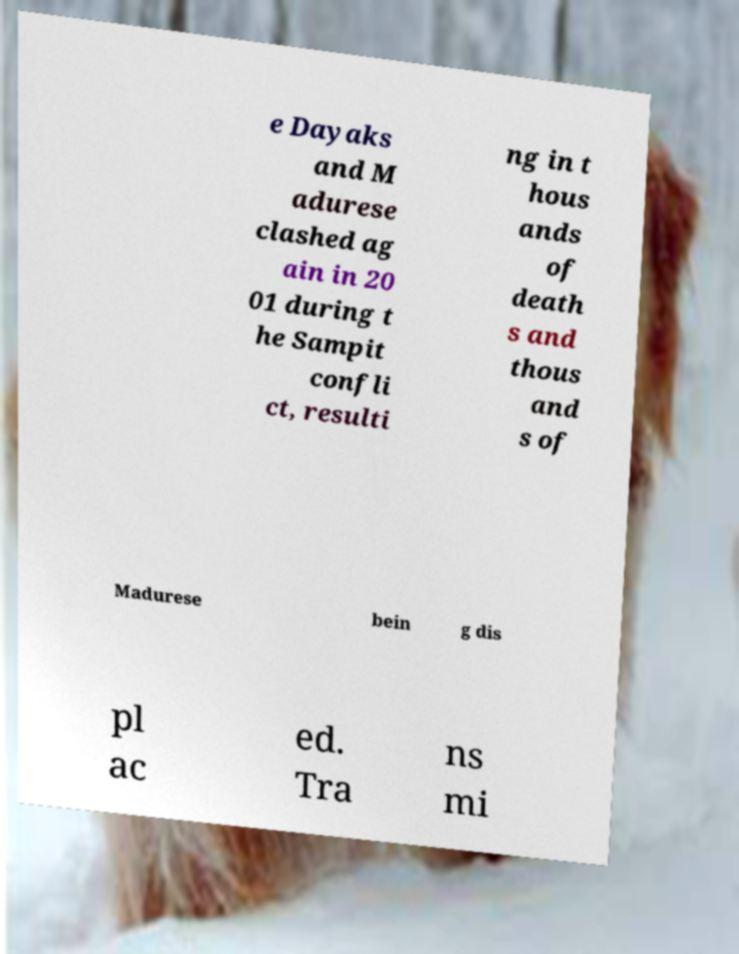For documentation purposes, I need the text within this image transcribed. Could you provide that? e Dayaks and M adurese clashed ag ain in 20 01 during t he Sampit confli ct, resulti ng in t hous ands of death s and thous and s of Madurese bein g dis pl ac ed. Tra ns mi 